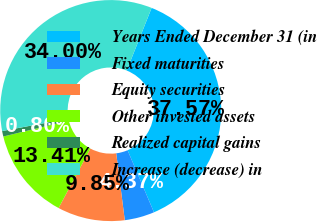<chart> <loc_0><loc_0><loc_500><loc_500><pie_chart><fcel>Years Ended December 31 (in<fcel>Fixed maturities<fcel>Equity securities<fcel>Other invested assets<fcel>Realized capital gains<fcel>Increase (decrease) in<nl><fcel>37.57%<fcel>4.37%<fcel>9.85%<fcel>13.41%<fcel>0.8%<fcel>34.0%<nl></chart> 